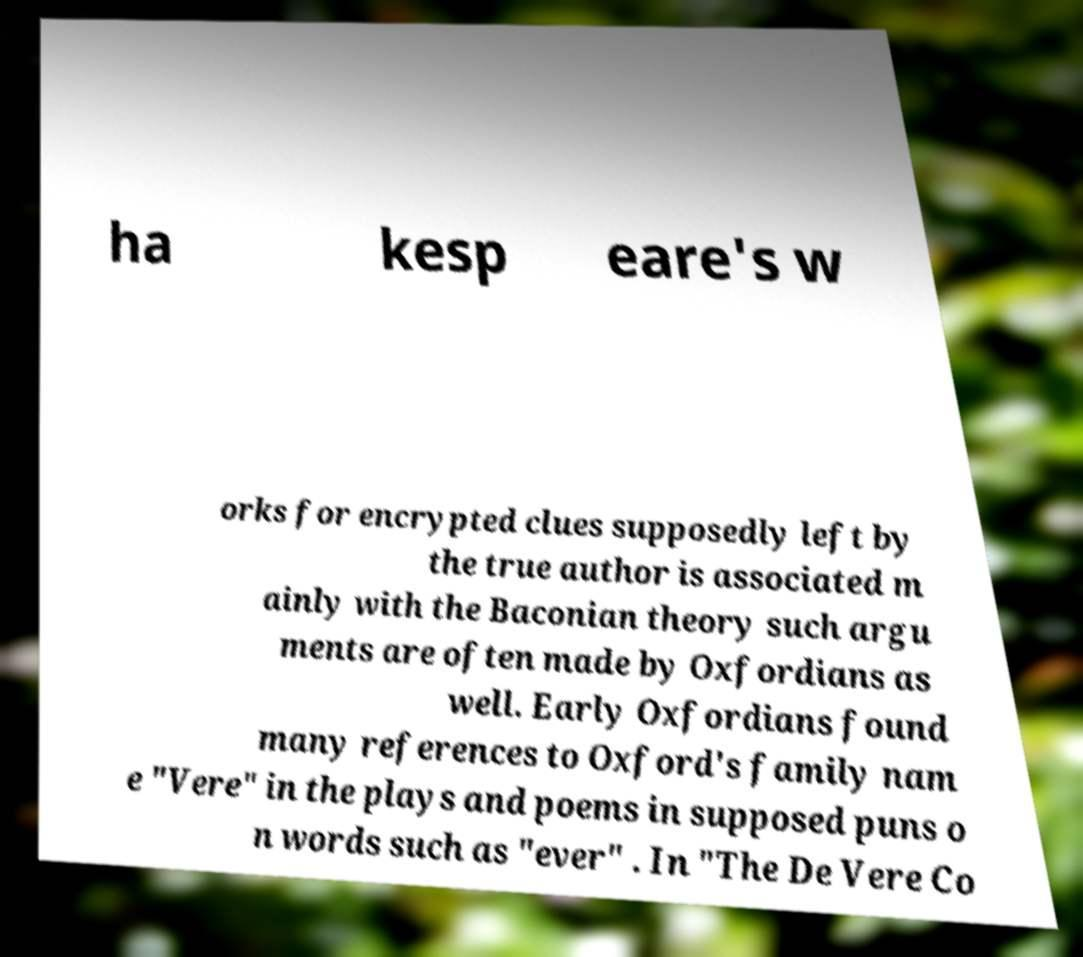Please read and relay the text visible in this image. What does it say? ha kesp eare's w orks for encrypted clues supposedly left by the true author is associated m ainly with the Baconian theory such argu ments are often made by Oxfordians as well. Early Oxfordians found many references to Oxford's family nam e "Vere" in the plays and poems in supposed puns o n words such as "ever" . In "The De Vere Co 